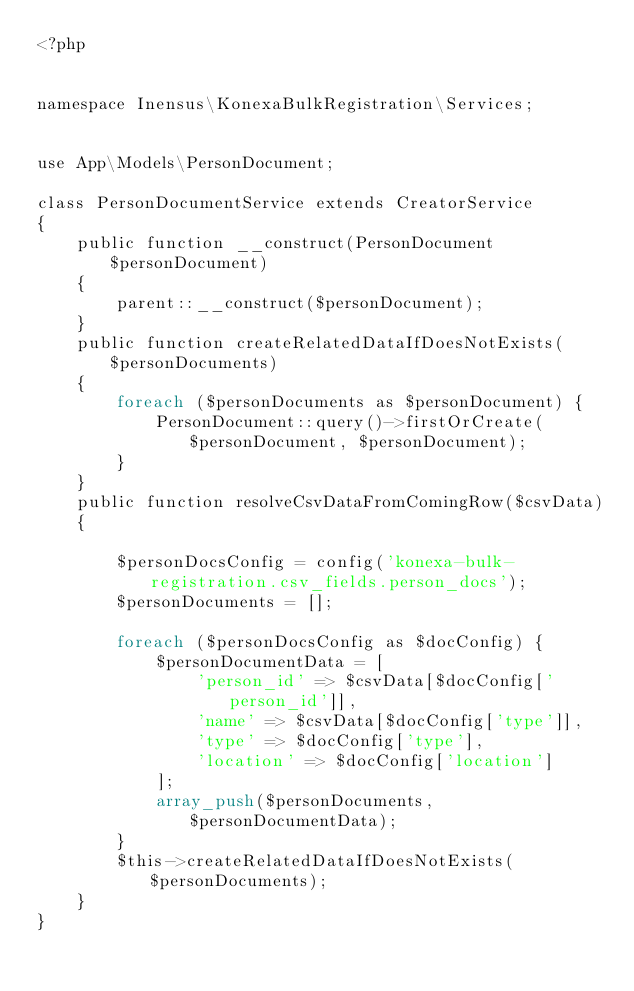Convert code to text. <code><loc_0><loc_0><loc_500><loc_500><_PHP_><?php


namespace Inensus\KonexaBulkRegistration\Services;


use App\Models\PersonDocument;

class PersonDocumentService extends CreatorService
{
    public function __construct(PersonDocument $personDocument)
    {
        parent::__construct($personDocument);
    }
    public function createRelatedDataIfDoesNotExists($personDocuments)
    {
        foreach ($personDocuments as $personDocument) {
            PersonDocument::query()->firstOrCreate($personDocument, $personDocument);
        }
    }
    public function resolveCsvDataFromComingRow($csvData)
    {

        $personDocsConfig = config('konexa-bulk-registration.csv_fields.person_docs');
        $personDocuments = [];

        foreach ($personDocsConfig as $docConfig) {
            $personDocumentData = [
                'person_id' => $csvData[$docConfig['person_id']],
                'name' => $csvData[$docConfig['type']],
                'type' => $docConfig['type'],
                'location' => $docConfig['location']
            ];
            array_push($personDocuments, $personDocumentData);
        }
        $this->createRelatedDataIfDoesNotExists($personDocuments);
    }
}</code> 